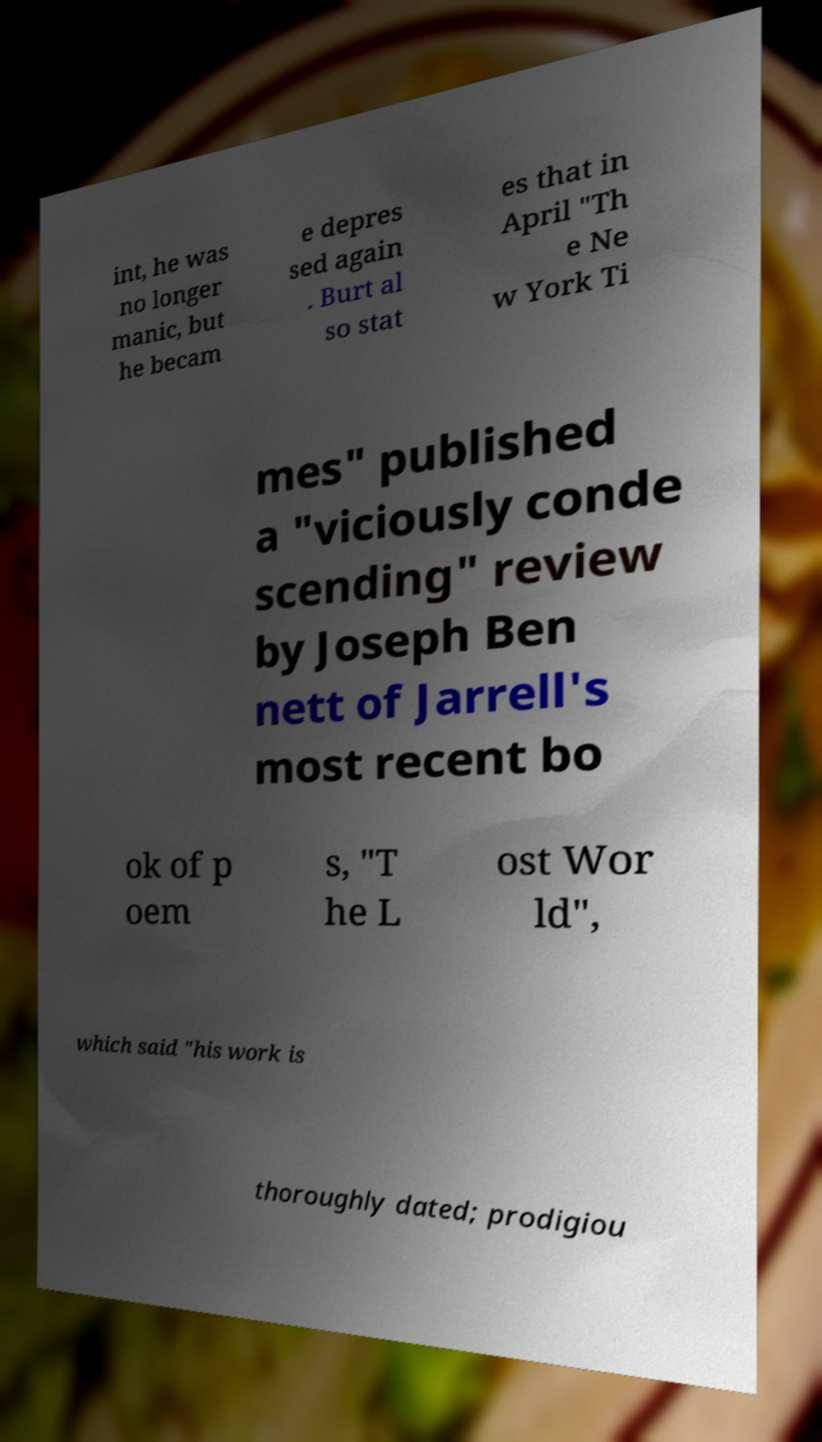Can you accurately transcribe the text from the provided image for me? int, he was no longer manic, but he becam e depres sed again . Burt al so stat es that in April "Th e Ne w York Ti mes" published a "viciously conde scending" review by Joseph Ben nett of Jarrell's most recent bo ok of p oem s, "T he L ost Wor ld", which said "his work is thoroughly dated; prodigiou 